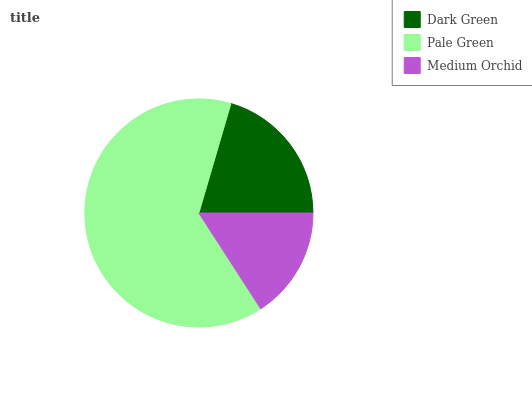Is Medium Orchid the minimum?
Answer yes or no. Yes. Is Pale Green the maximum?
Answer yes or no. Yes. Is Pale Green the minimum?
Answer yes or no. No. Is Medium Orchid the maximum?
Answer yes or no. No. Is Pale Green greater than Medium Orchid?
Answer yes or no. Yes. Is Medium Orchid less than Pale Green?
Answer yes or no. Yes. Is Medium Orchid greater than Pale Green?
Answer yes or no. No. Is Pale Green less than Medium Orchid?
Answer yes or no. No. Is Dark Green the high median?
Answer yes or no. Yes. Is Dark Green the low median?
Answer yes or no. Yes. Is Medium Orchid the high median?
Answer yes or no. No. Is Pale Green the low median?
Answer yes or no. No. 